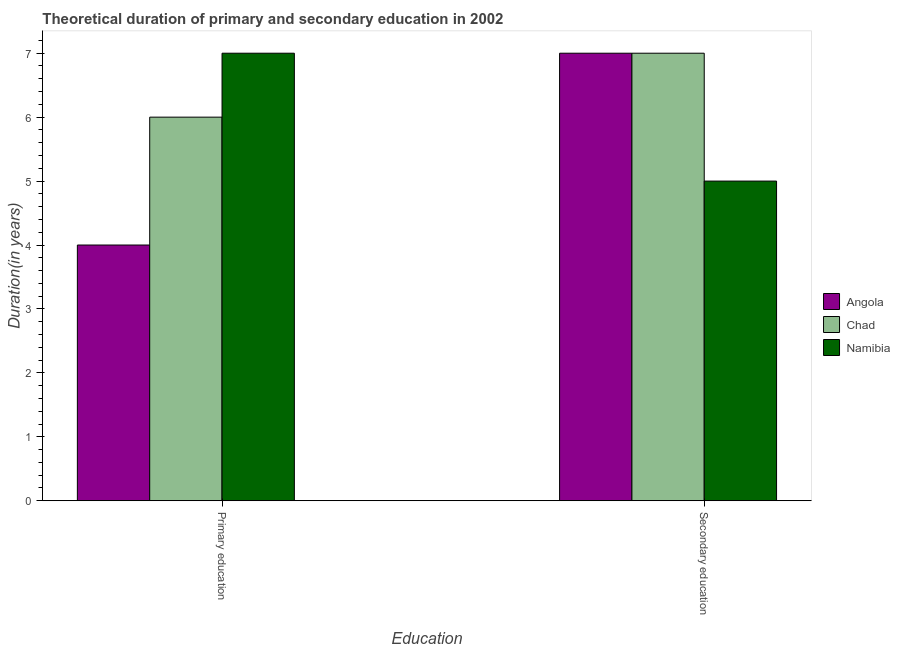How many groups of bars are there?
Your response must be concise. 2. Are the number of bars on each tick of the X-axis equal?
Your answer should be compact. Yes. How many bars are there on the 2nd tick from the right?
Your answer should be very brief. 3. What is the label of the 1st group of bars from the left?
Offer a terse response. Primary education. What is the duration of primary education in Angola?
Offer a very short reply. 4. Across all countries, what is the maximum duration of secondary education?
Ensure brevity in your answer.  7. Across all countries, what is the minimum duration of primary education?
Your answer should be compact. 4. In which country was the duration of primary education maximum?
Your response must be concise. Namibia. In which country was the duration of primary education minimum?
Give a very brief answer. Angola. What is the total duration of primary education in the graph?
Keep it short and to the point. 17. What is the difference between the duration of secondary education in Namibia and that in Chad?
Keep it short and to the point. -2. What is the difference between the duration of secondary education in Chad and the duration of primary education in Angola?
Make the answer very short. 3. What is the average duration of secondary education per country?
Your answer should be very brief. 6.33. What is the difference between the duration of secondary education and duration of primary education in Angola?
Your answer should be compact. 3. In how many countries, is the duration of secondary education greater than 7 years?
Ensure brevity in your answer.  0. What is the ratio of the duration of primary education in Angola to that in Chad?
Ensure brevity in your answer.  0.67. What does the 2nd bar from the left in Secondary education represents?
Give a very brief answer. Chad. What does the 2nd bar from the right in Primary education represents?
Offer a terse response. Chad. How many countries are there in the graph?
Keep it short and to the point. 3. Are the values on the major ticks of Y-axis written in scientific E-notation?
Your answer should be very brief. No. Does the graph contain any zero values?
Offer a very short reply. No. Does the graph contain grids?
Offer a very short reply. No. Where does the legend appear in the graph?
Your answer should be compact. Center right. What is the title of the graph?
Provide a succinct answer. Theoretical duration of primary and secondary education in 2002. Does "Australia" appear as one of the legend labels in the graph?
Ensure brevity in your answer.  No. What is the label or title of the X-axis?
Provide a succinct answer. Education. What is the label or title of the Y-axis?
Offer a terse response. Duration(in years). What is the Duration(in years) in Chad in Secondary education?
Provide a succinct answer. 7. What is the Duration(in years) of Namibia in Secondary education?
Ensure brevity in your answer.  5. Across all Education, what is the maximum Duration(in years) in Angola?
Ensure brevity in your answer.  7. Across all Education, what is the maximum Duration(in years) of Namibia?
Provide a short and direct response. 7. Across all Education, what is the minimum Duration(in years) in Chad?
Give a very brief answer. 6. Across all Education, what is the minimum Duration(in years) in Namibia?
Your response must be concise. 5. What is the total Duration(in years) in Chad in the graph?
Your answer should be very brief. 13. What is the difference between the Duration(in years) in Chad in Primary education and that in Secondary education?
Ensure brevity in your answer.  -1. What is the difference between the Duration(in years) of Angola in Primary education and the Duration(in years) of Chad in Secondary education?
Give a very brief answer. -3. What is the difference between the Duration(in years) in Chad in Primary education and the Duration(in years) in Namibia in Secondary education?
Ensure brevity in your answer.  1. What is the average Duration(in years) in Angola per Education?
Give a very brief answer. 5.5. What is the average Duration(in years) in Chad per Education?
Provide a short and direct response. 6.5. What is the difference between the Duration(in years) of Angola and Duration(in years) of Namibia in Primary education?
Your response must be concise. -3. What is the difference between the highest and the lowest Duration(in years) of Chad?
Your response must be concise. 1. 